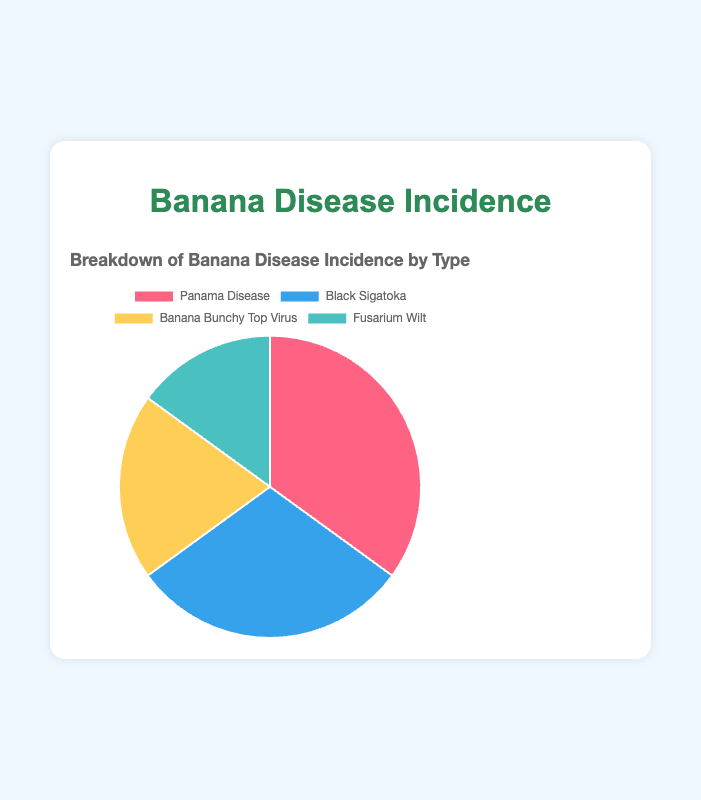What percentage of banana plants are affected by Panama Disease? The pie chart shows the percentage of banana plants affected by each disease. The slice for Panama Disease is labeled with 35%.
Answer: 35% What is the total percentage of banana plants affected by Black Sigatoka and Fusarium Wilt combined? To find the combined percentage, add the incidence percentages of Black Sigatoka (30%) and Fusarium Wilt (15%). Thus, 30% + 15% = 45%.
Answer: 45% Which disease has the lowest incidence? The pie chart shows the percentages of each disease. Fusarium Wilt has the lowest incidence at 15%.
Answer: Fusarium Wilt How does the incidence of Banana Bunchy Top Virus compare to Black Sigatoka? The pie chart shows Banana Bunchy Top Virus at 20% and Black Sigatoka at 30%. 20% is less than 30%, so Banana Bunchy Top Virus has a lower incidence.
Answer: Banana Bunchy Top Virus has a lower incidence than Black Sigatoka What is the difference in incidence rates between Panama Disease and Fusarium Wilt? Subtract the incidence percentage of Fusarium Wilt (15%) from Panama Disease (35%). Thus, 35% - 15% = 20%.
Answer: 20% Which disease is represented by the green color in the pie chart? By examining the colors associated with each slice of the pie chart: Panama Disease (red), Black Sigatoka (blue), Banana Bunchy Top Virus (yellow), and Fusarium Wilt (green). Therefore, Fusarium Wilt is represented by the green color.
Answer: Fusarium Wilt If you were to rank the diseases by their incidence rates from highest to lowest, what would be the order? The incidence rates shown in the pie chart are: Panama Disease (35%), Black Sigatoka (30%), Banana Bunchy Top Virus (20%), and Fusarium Wilt (15%). Ranking them from highest to lowest gives: 1. Panama Disease, 2. Black Sigatoka, 3. Banana Bunchy Top Virus, 4. Fusarium Wilt.
Answer: Panama Disease, Black Sigatoka, Banana Bunchy Top Virus, Fusarium Wilt What is the average incidence rate of all diseases? To find the average incidence, sum up the incidence percentages and divide by the number of diseases. (35% + 30% + 20% + 15%) / 4 = 25%.
Answer: 25% Which two diseases combined represent over half of the total incidence? Combining Panama Disease (35%) and Black Sigatoka (30%) yields 65%, which is over half (50%) of the total.
Answer: Panama Disease and Black Sigatoka 